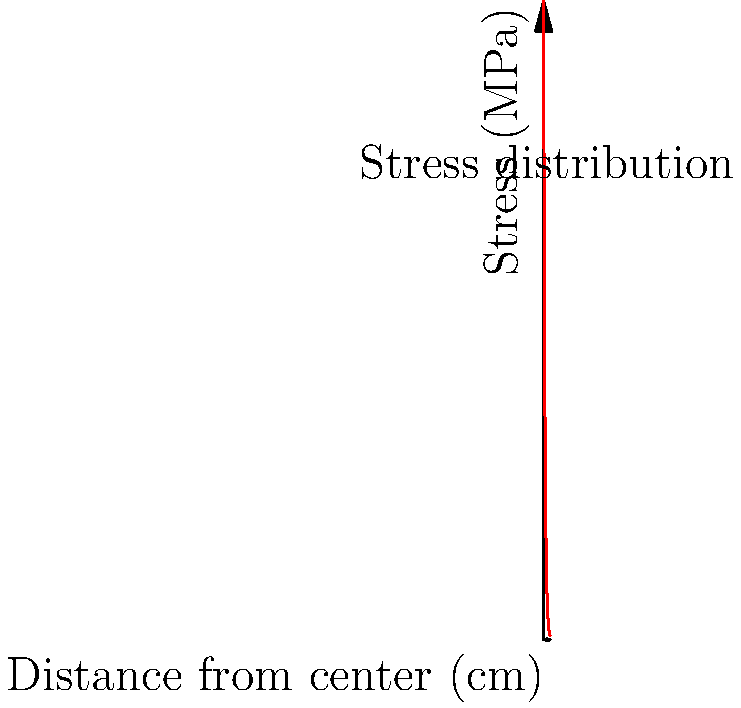Consider the stress distribution in a rusty old mining cart wheel, as shown in the graph above. The stress decreases exponentially from the center to the edge of the wheel. If the maximum stress at the center is 1000 MPa, at what distance from the center (in cm) does the stress reduce to 500 MPa? To solve this problem, we need to follow these steps:

1. Identify the equation for exponential decay:
   $$S = S_0 e^{-kx}$$
   where $S$ is the stress at distance $x$, $S_0$ is the initial stress, and $k$ is the decay constant.

2. We know that:
   - $S_0 = 1000$ MPa (initial stress at the center)
   - $S = 500$ MPa (stress we're looking for)
   - We need to find $x$

3. Substitute the known values into the equation:
   $$500 = 1000 e^{-kx}$$

4. Simplify:
   $$\frac{1}{2} = e^{-kx}$$

5. Take the natural logarithm of both sides:
   $$\ln(\frac{1}{2}) = -kx$$

6. Solve for $x$:
   $$x = -\frac{\ln(\frac{1}{2})}{k}$$

7. From the graph, we can see that the stress reduces by half at around 1.4 cm. This means:
   $$1.4 = -\frac{\ln(\frac{1}{2})}{k}$$

8. Solve for $k$:
   $$k = -\frac{\ln(\frac{1}{2})}{1.4} \approx 0.495$$

9. Now we can find $x$:
   $$x = -\frac{\ln(\frac{1}{2})}{0.495} \approx 1.4 \text{ cm}$$

Therefore, the stress reduces to 500 MPa at approximately 1.4 cm from the center of the wheel.
Answer: 1.4 cm 